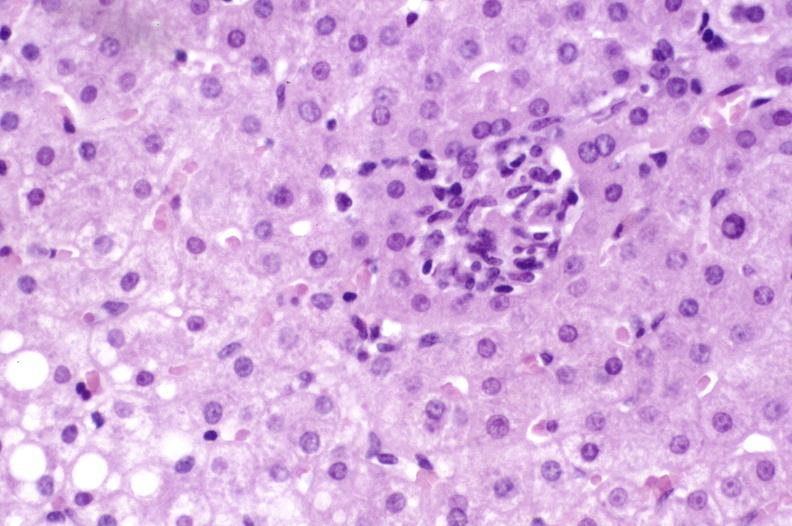s liver present?
Answer the question using a single word or phrase. Yes 